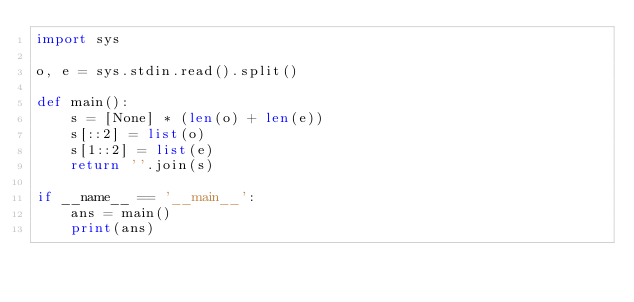Convert code to text. <code><loc_0><loc_0><loc_500><loc_500><_Python_>import sys

o, e = sys.stdin.read().split()

def main():
    s = [None] * (len(o) + len(e))
    s[::2] = list(o)
    s[1::2] = list(e)
    return ''.join(s)

if __name__ == '__main__':
    ans = main()
    print(ans)</code> 